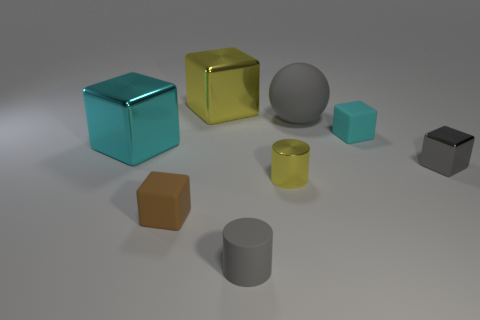Subtract all big cyan shiny blocks. How many blocks are left? 4 Add 2 cyan cylinders. How many objects exist? 10 Subtract all gray blocks. How many blocks are left? 4 Subtract all cubes. How many objects are left? 3 Subtract 2 cylinders. How many cylinders are left? 0 Subtract all yellow spheres. Subtract all brown cylinders. How many spheres are left? 1 Add 6 tiny gray metallic cubes. How many tiny gray metallic cubes are left? 7 Add 5 big matte balls. How many big matte balls exist? 6 Subtract 0 yellow balls. How many objects are left? 8 Subtract all red balls. How many cyan cylinders are left? 0 